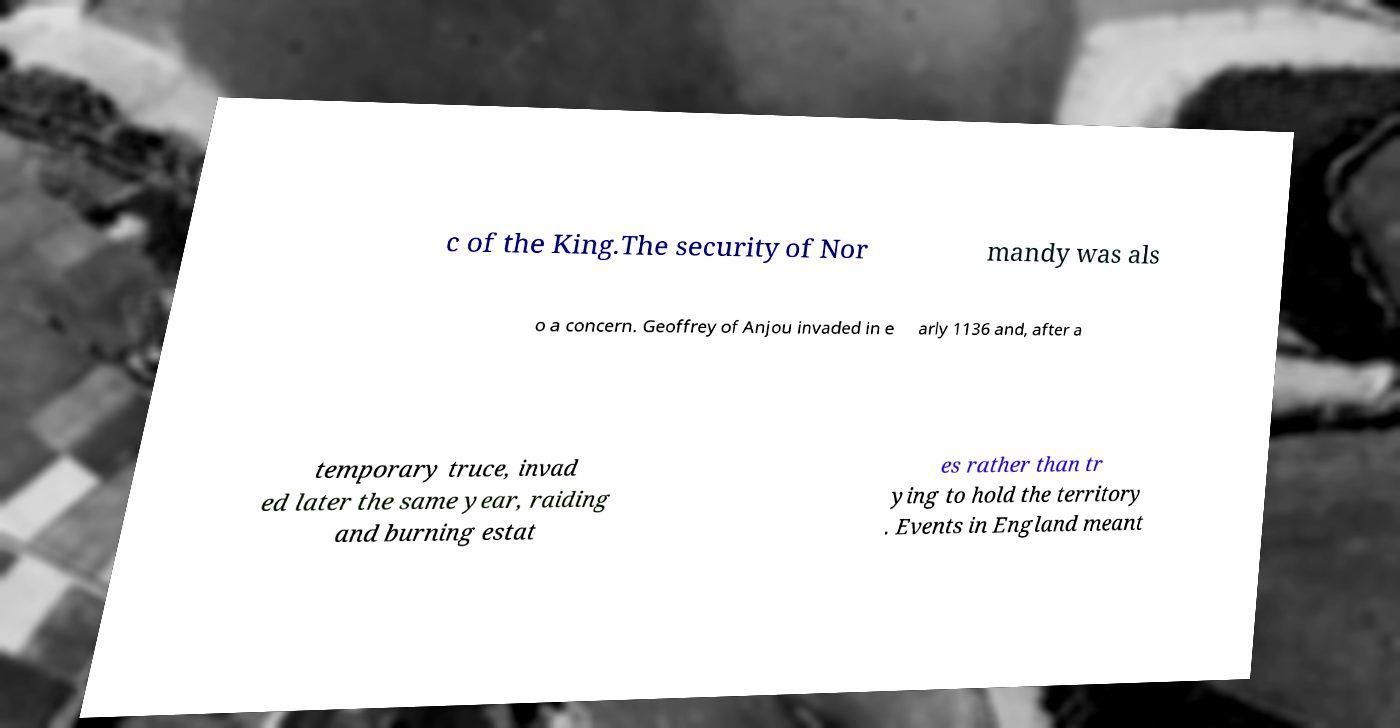Can you read and provide the text displayed in the image?This photo seems to have some interesting text. Can you extract and type it out for me? c of the King.The security of Nor mandy was als o a concern. Geoffrey of Anjou invaded in e arly 1136 and, after a temporary truce, invad ed later the same year, raiding and burning estat es rather than tr ying to hold the territory . Events in England meant 